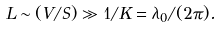Convert formula to latex. <formula><loc_0><loc_0><loc_500><loc_500>L \sim ( V / S ) \gg 1 / K = \lambda _ { 0 } / ( 2 \pi ) .</formula> 